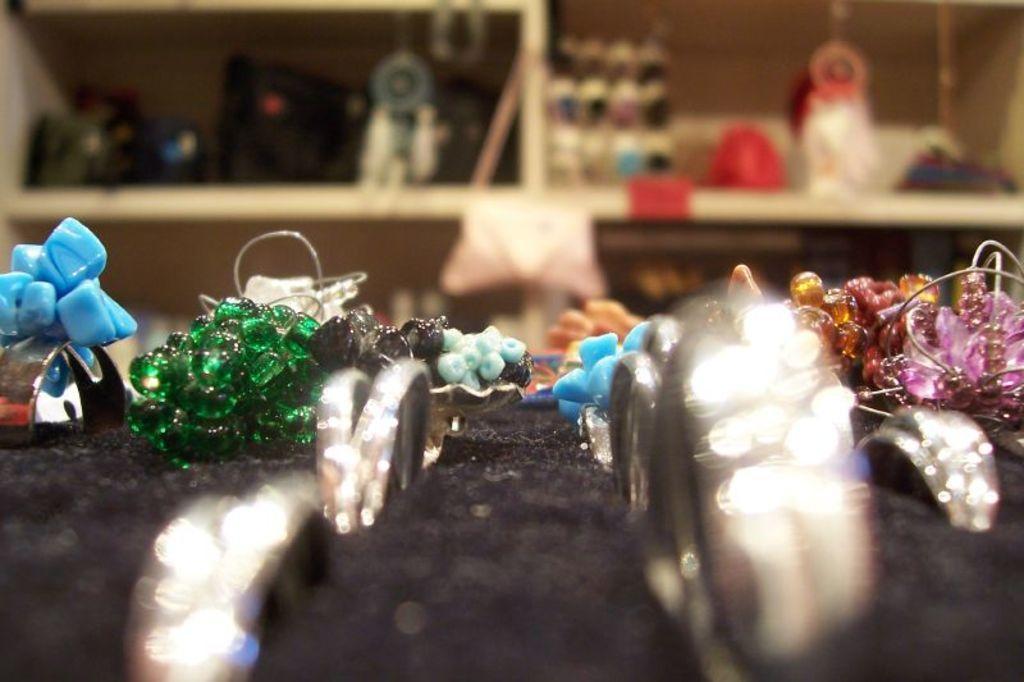Can you describe this image briefly? In this picture I can see some accessories on a black object, and in the background there are some items in the shelves. 